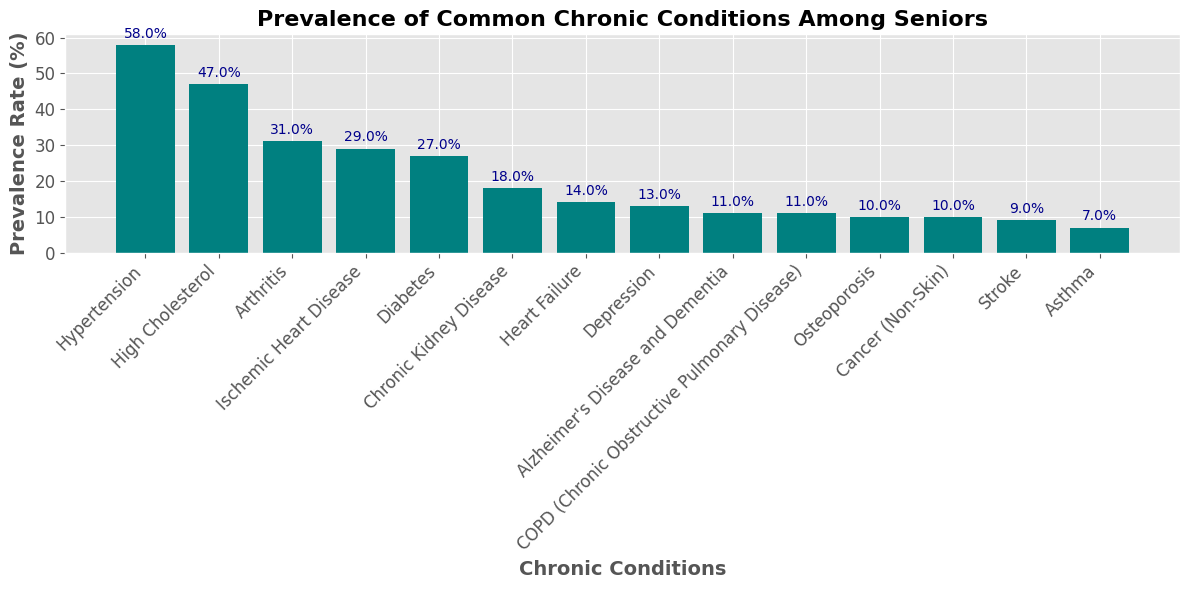Which chronic condition has the highest prevalence rate among seniors? By inspecting the heights of the bars in the bar chart, the tallest bar represents the condition with the highest prevalence rate.
Answer: Hypertension How much more prevalent is Hypertension compared to Diabetes? From the chart, the prevalence rate for Hypertension is 58%, while Diabetes has a prevalence rate of 27%. The difference is 58% - 27% = 31%.
Answer: 31% What is the combined prevalence rate of Alzheimer's Disease and Dementia, and COPD? The prevalence rates are 11% for Alzheimer's Disease and Dementia and 11% for COPD. Summing these rates: 11% + 11% = 22%.
Answer: 22% Which has a higher prevalence rate: Depression or Cancer (Non-Skin)? By comparing the heights of the respective bars, the bar for Depression (13%) is taller than the bar for Cancer (Non-Skin) (10%).
Answer: Depression What is the average prevalence rate of the three most common chronic conditions among seniors? The three most common chronic conditions are Hypertension (58%), High Cholesterol (47%), and Arthritis (31%). The average is calculated as (58% + 47% + 31%) / 3 = 136% / 3 ≈ 45.33%.
Answer: 45.33% Is the prevalence rate of Chronic Kidney Disease more than double that of Stroke? The prevalence rate for Chronic Kidney Disease is 18%, while for Stroke, it is 9%. Checking if 18% is more than double 9%: 2 * 9% = 18%, so it is exactly double.
Answer: No Rank the top three chronic conditions by their prevalence rates. By examining the heights of the bars, the top three conditions are Hypertension (58%), High Cholesterol (47%), and Arthritis (31%).
Answer: Hypertension, High Cholesterol, Arthritis Does Asthma have a higher prevalence rate than Osteoporosis? By comparing the heights of the bars, Osteoporosis has a prevalence rate of 10%, while Asthma has a prevalence rate of 7%. Asthma is lower than Osteoporosis.
Answer: No Which condition is just as prevalent as COPD? The prevalence rate for COPD is 11%. The same height is observed for Alzheimer's Disease and Dementia also with 11%.
Answer: Alzheimer's Disease and Dementia 